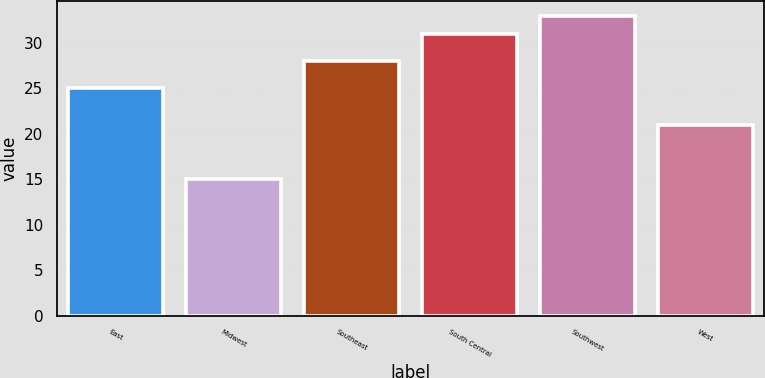Convert chart to OTSL. <chart><loc_0><loc_0><loc_500><loc_500><bar_chart><fcel>East<fcel>Midwest<fcel>Southeast<fcel>South Central<fcel>Southwest<fcel>West<nl><fcel>25<fcel>15<fcel>28<fcel>31<fcel>33<fcel>21<nl></chart> 